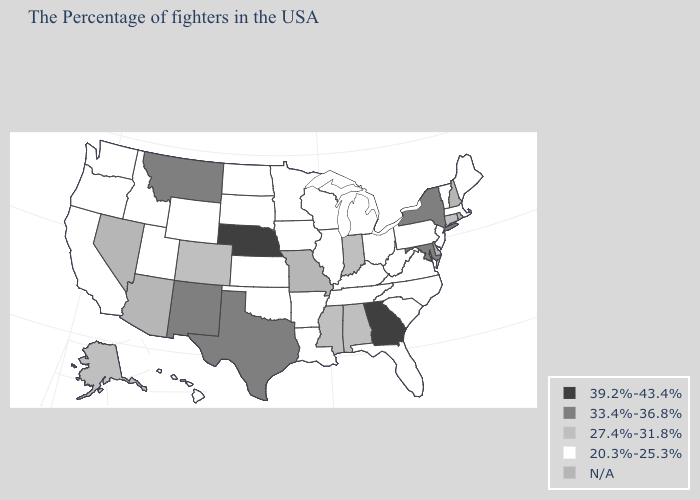What is the value of Arizona?
Keep it brief. N/A. Does the first symbol in the legend represent the smallest category?
Short answer required. No. Name the states that have a value in the range 20.3%-25.3%?
Give a very brief answer. Maine, Massachusetts, Vermont, New Jersey, Pennsylvania, Virginia, North Carolina, South Carolina, West Virginia, Ohio, Florida, Michigan, Kentucky, Tennessee, Wisconsin, Illinois, Louisiana, Arkansas, Minnesota, Iowa, Kansas, Oklahoma, South Dakota, North Dakota, Wyoming, Utah, Idaho, California, Washington, Oregon, Hawaii. Name the states that have a value in the range 33.4%-36.8%?
Be succinct. New York, Maryland, Texas, New Mexico, Montana. Name the states that have a value in the range N/A?
Write a very short answer. Rhode Island, New Hampshire, Delaware, Missouri, Arizona, Nevada. Name the states that have a value in the range 27.4%-31.8%?
Short answer required. Connecticut, Indiana, Alabama, Mississippi, Colorado, Alaska. Name the states that have a value in the range 39.2%-43.4%?
Be succinct. Georgia, Nebraska. Name the states that have a value in the range 20.3%-25.3%?
Give a very brief answer. Maine, Massachusetts, Vermont, New Jersey, Pennsylvania, Virginia, North Carolina, South Carolina, West Virginia, Ohio, Florida, Michigan, Kentucky, Tennessee, Wisconsin, Illinois, Louisiana, Arkansas, Minnesota, Iowa, Kansas, Oklahoma, South Dakota, North Dakota, Wyoming, Utah, Idaho, California, Washington, Oregon, Hawaii. What is the value of South Carolina?
Be succinct. 20.3%-25.3%. Name the states that have a value in the range N/A?
Answer briefly. Rhode Island, New Hampshire, Delaware, Missouri, Arizona, Nevada. Which states have the lowest value in the USA?
Answer briefly. Maine, Massachusetts, Vermont, New Jersey, Pennsylvania, Virginia, North Carolina, South Carolina, West Virginia, Ohio, Florida, Michigan, Kentucky, Tennessee, Wisconsin, Illinois, Louisiana, Arkansas, Minnesota, Iowa, Kansas, Oklahoma, South Dakota, North Dakota, Wyoming, Utah, Idaho, California, Washington, Oregon, Hawaii. How many symbols are there in the legend?
Write a very short answer. 5. Name the states that have a value in the range 33.4%-36.8%?
Quick response, please. New York, Maryland, Texas, New Mexico, Montana. 